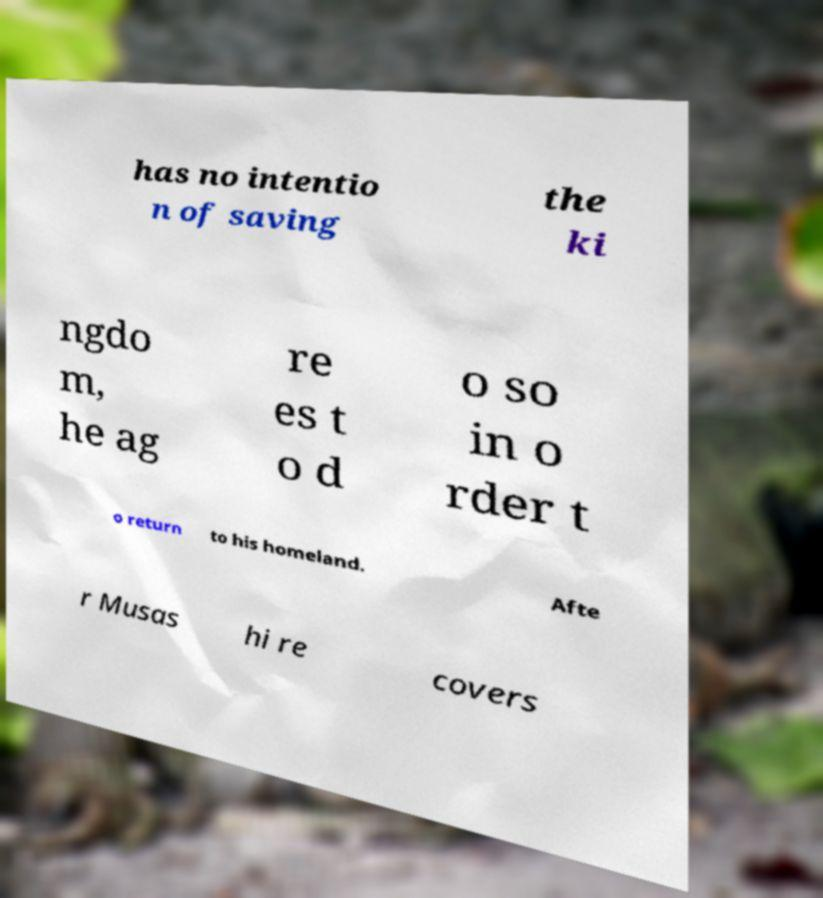There's text embedded in this image that I need extracted. Can you transcribe it verbatim? has no intentio n of saving the ki ngdo m, he ag re es t o d o so in o rder t o return to his homeland. Afte r Musas hi re covers 